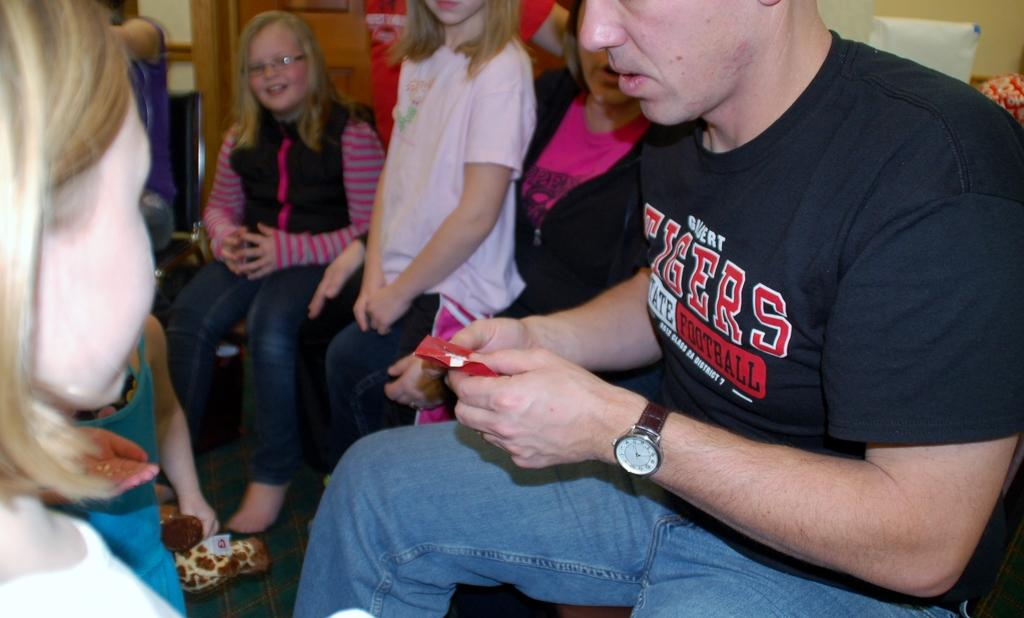What are the people in the image doing? The people in the image are sitting on chairs. What is the man holding in his hands? The man is holding a paper in his hands. What can be seen in the background of the image? There is a wall and objects visible in the background of the image. What type of reaction can be seen on the pies in the image? There are no pies present in the image, so it is not possible to determine any reactions on them. 